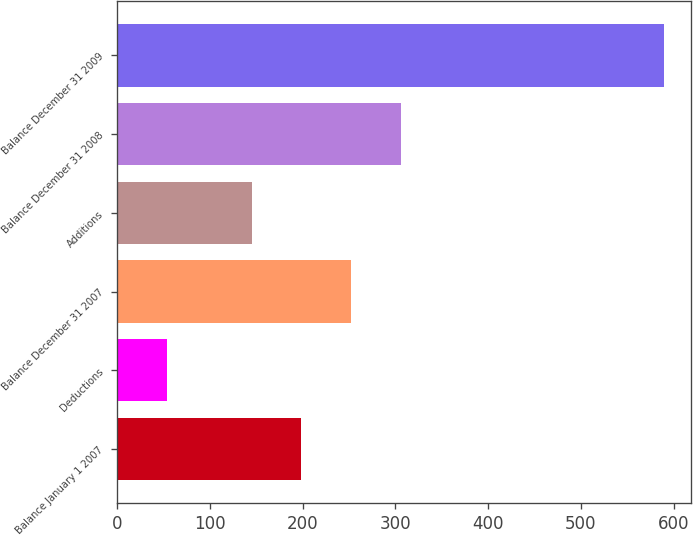<chart> <loc_0><loc_0><loc_500><loc_500><bar_chart><fcel>Balance January 1 2007<fcel>Deductions<fcel>Balance December 31 2007<fcel>Additions<fcel>Balance December 31 2008<fcel>Balance December 31 2009<nl><fcel>198.5<fcel>54<fcel>252<fcel>145<fcel>305.5<fcel>589<nl></chart> 